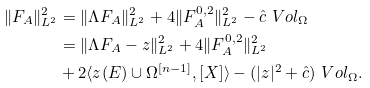<formula> <loc_0><loc_0><loc_500><loc_500>\| F _ { A } \| ^ { 2 } _ { L ^ { 2 } } & = \| \Lambda F _ { A } \| ^ { 2 } _ { L ^ { 2 } } + 4 \| F _ { A } ^ { 0 , 2 } \| ^ { 2 } _ { L ^ { 2 } } - \hat { c } \ V o l _ { \Omega } \\ & = \| \Lambda F _ { A } - z \| ^ { 2 } _ { L ^ { 2 } } + 4 \| F _ { A } ^ { 0 , 2 } \| ^ { 2 } _ { L ^ { 2 } } \\ & + 2 \langle z ( E ) \cup \Omega ^ { [ n - 1 ] } , [ X ] \rangle - ( | z | ^ { 2 } + \hat { c } ) \ V o l _ { \Omega } .</formula> 